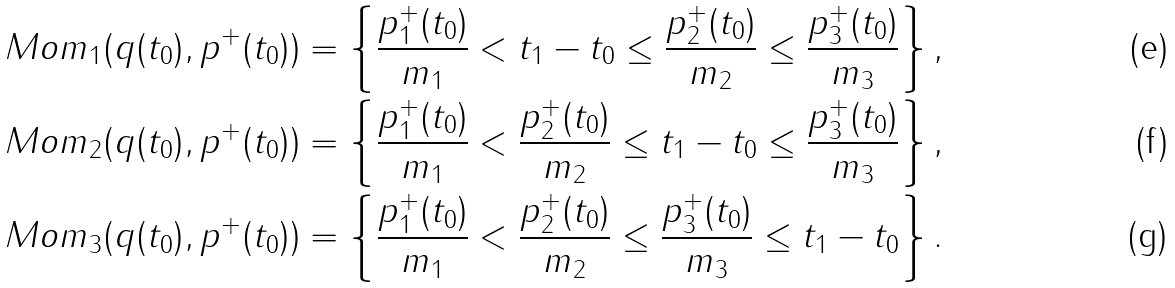Convert formula to latex. <formula><loc_0><loc_0><loc_500><loc_500>& M o m _ { 1 } ( q ( t _ { 0 } ) , p ^ { + } ( t _ { 0 } ) ) = \left \{ \frac { p _ { 1 } ^ { + } ( t _ { 0 } ) } { m _ { 1 } } < t _ { 1 } - t _ { 0 } \leq \frac { p _ { 2 } ^ { + } ( t _ { 0 } ) } { m _ { 2 } } \leq \frac { p _ { 3 } ^ { + } ( t _ { 0 } ) } { m _ { 3 } } \right \} , \\ & M o m _ { 2 } ( q ( t _ { 0 } ) , p ^ { + } ( t _ { 0 } ) ) = \left \{ \frac { p _ { 1 } ^ { + } ( t _ { 0 } ) } { m _ { 1 } } < \frac { p _ { 2 } ^ { + } ( t _ { 0 } ) } { m _ { 2 } } \leq t _ { 1 } - t _ { 0 } \leq \frac { p _ { 3 } ^ { + } ( t _ { 0 } ) } { m _ { 3 } } \right \} , \\ & M o m _ { 3 } ( q ( t _ { 0 } ) , p ^ { + } ( t _ { 0 } ) ) = \left \{ \frac { p _ { 1 } ^ { + } ( t _ { 0 } ) } { m _ { 1 } } < \frac { p _ { 2 } ^ { + } ( t _ { 0 } ) } { m _ { 2 } } \leq \frac { p _ { 3 } ^ { + } ( t _ { 0 } ) } { m _ { 3 } } \leq t _ { 1 } - t _ { 0 } \right \} .</formula> 